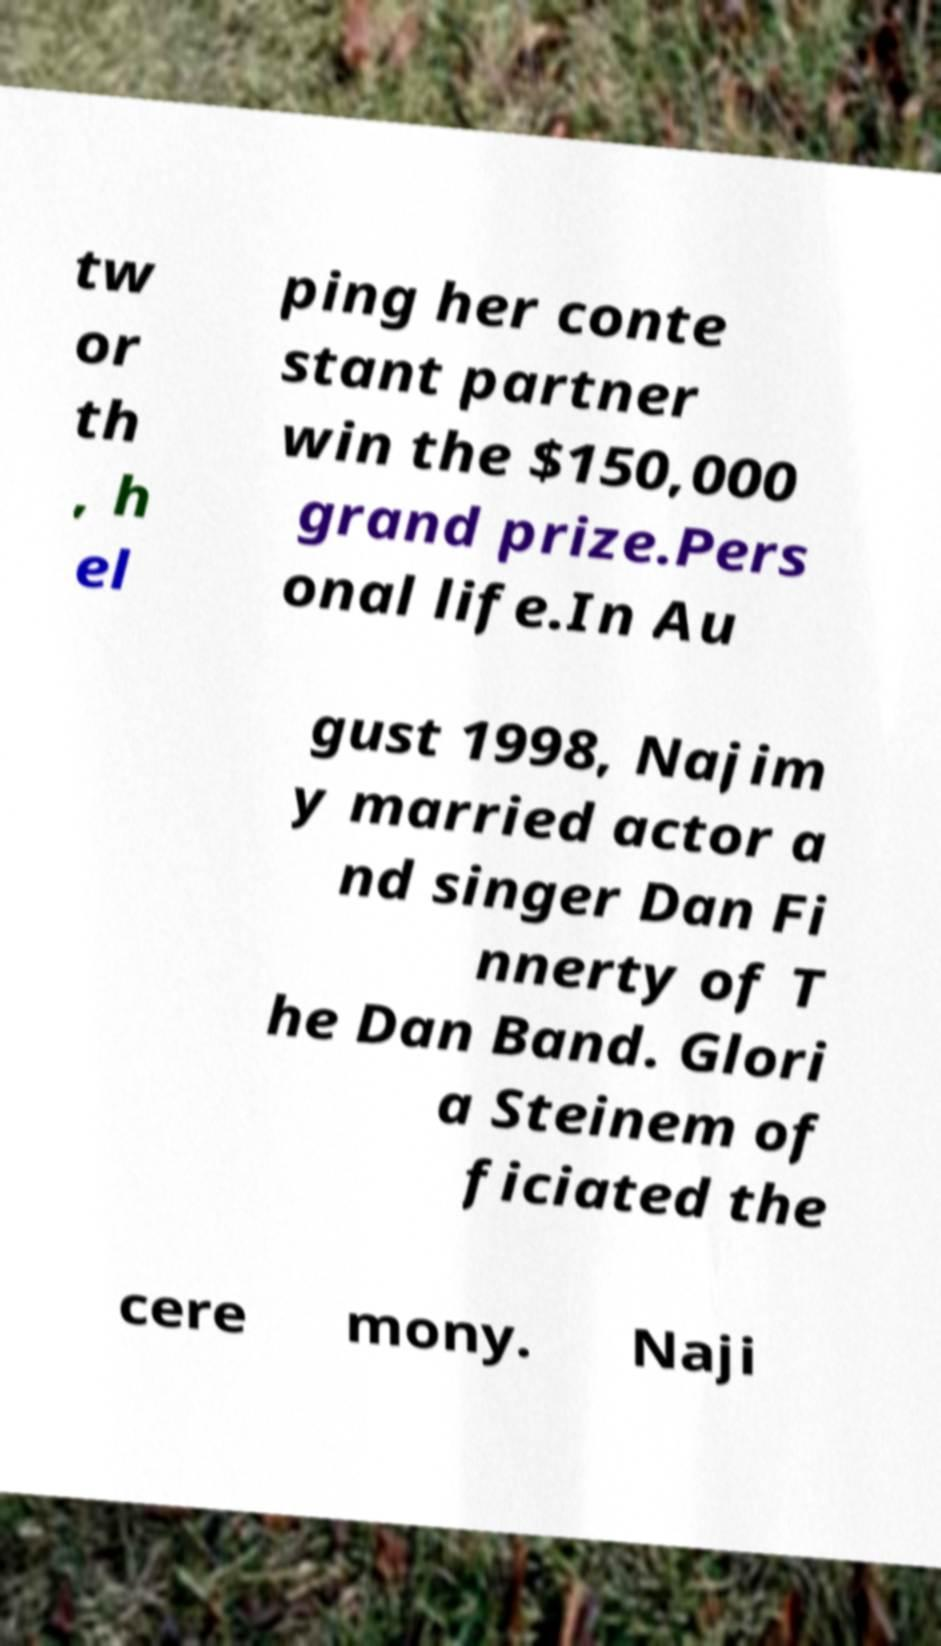I need the written content from this picture converted into text. Can you do that? tw or th , h el ping her conte stant partner win the $150,000 grand prize.Pers onal life.In Au gust 1998, Najim y married actor a nd singer Dan Fi nnerty of T he Dan Band. Glori a Steinem of ficiated the cere mony. Naji 